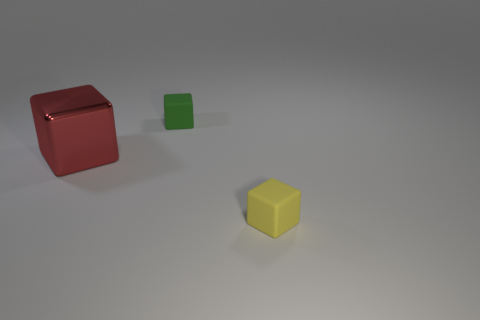What number of yellow things are small blocks or cubes?
Make the answer very short. 1. What number of other things are there of the same size as the metal thing?
Your answer should be very brief. 0. What number of big things are cyan cubes or red cubes?
Your answer should be very brief. 1. Does the yellow block have the same size as the rubber object behind the yellow rubber object?
Your answer should be compact. Yes. How many other objects are the same shape as the green rubber object?
Provide a succinct answer. 2. What shape is the yellow object that is made of the same material as the green thing?
Offer a very short reply. Cube. Are any yellow objects visible?
Provide a succinct answer. Yes. Are there fewer yellow matte cubes on the right side of the small yellow rubber thing than big things in front of the red metallic thing?
Offer a terse response. No. The small rubber object in front of the green rubber object has what shape?
Your answer should be compact. Cube. Are the red block and the small green thing made of the same material?
Provide a succinct answer. No. 